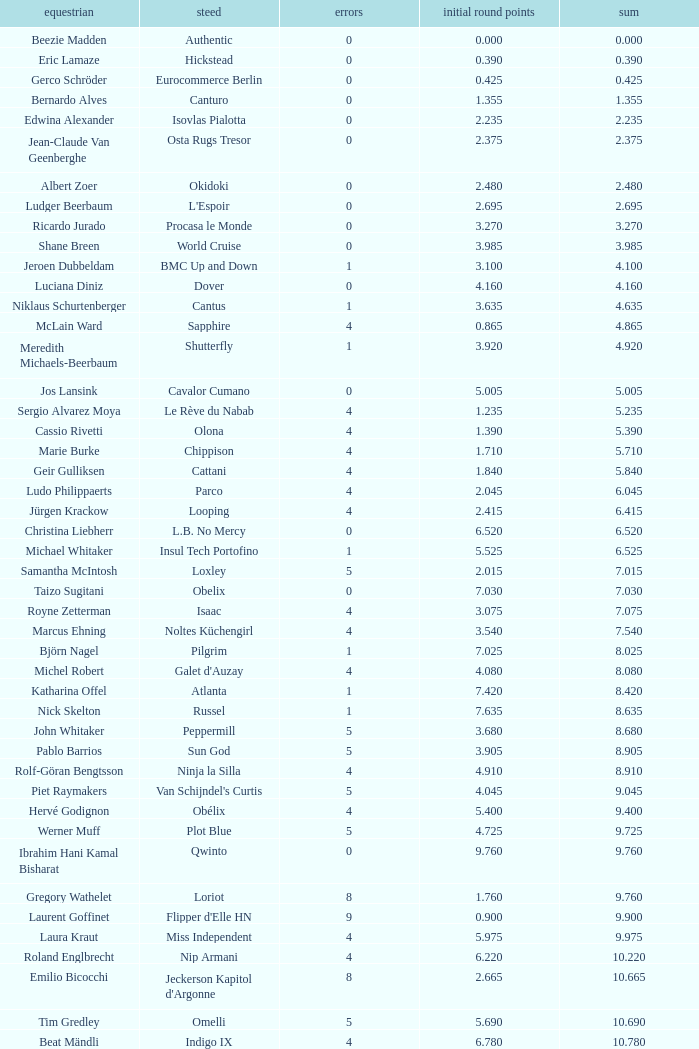Tell me the rider with 18.185 points round 1 Veronika Macanova. 